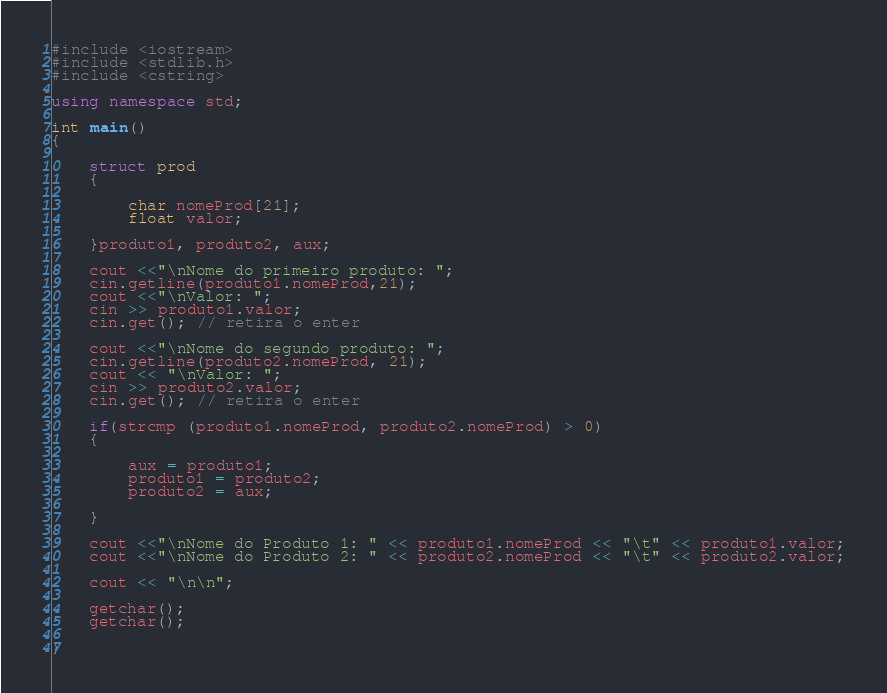Convert code to text. <code><loc_0><loc_0><loc_500><loc_500><_C++_>#include <iostream>
#include <stdlib.h>
#include <cstring>

using namespace std;

int main()
{

    struct prod
    {

        char nomeProd[21];
        float valor;

    }produto1, produto2, aux;

    cout <<"\nNome do primeiro produto: ";
    cin.getline(produto1.nomeProd,21);
    cout <<"\nValor: ";
    cin >> produto1.valor;
    cin.get(); // retira o enter

    cout <<"\nNome do segundo produto: ";
    cin.getline(produto2.nomeProd, 21);
    cout << "\nValor: ";
    cin >> produto2.valor;
    cin.get(); // retira o enter

    if(strcmp (produto1.nomeProd, produto2.nomeProd) > 0)
    {

        aux = produto1; 
        produto1 = produto2;
        produto2 = aux;

    }    

    cout <<"\nNome do Produto 1: " << produto1.nomeProd << "\t" << produto1.valor;
    cout <<"\nNome do Produto 2: " << produto2.nomeProd << "\t" << produto2.valor;

    cout << "\n\n";

    getchar();
    getchar();

}

</code> 